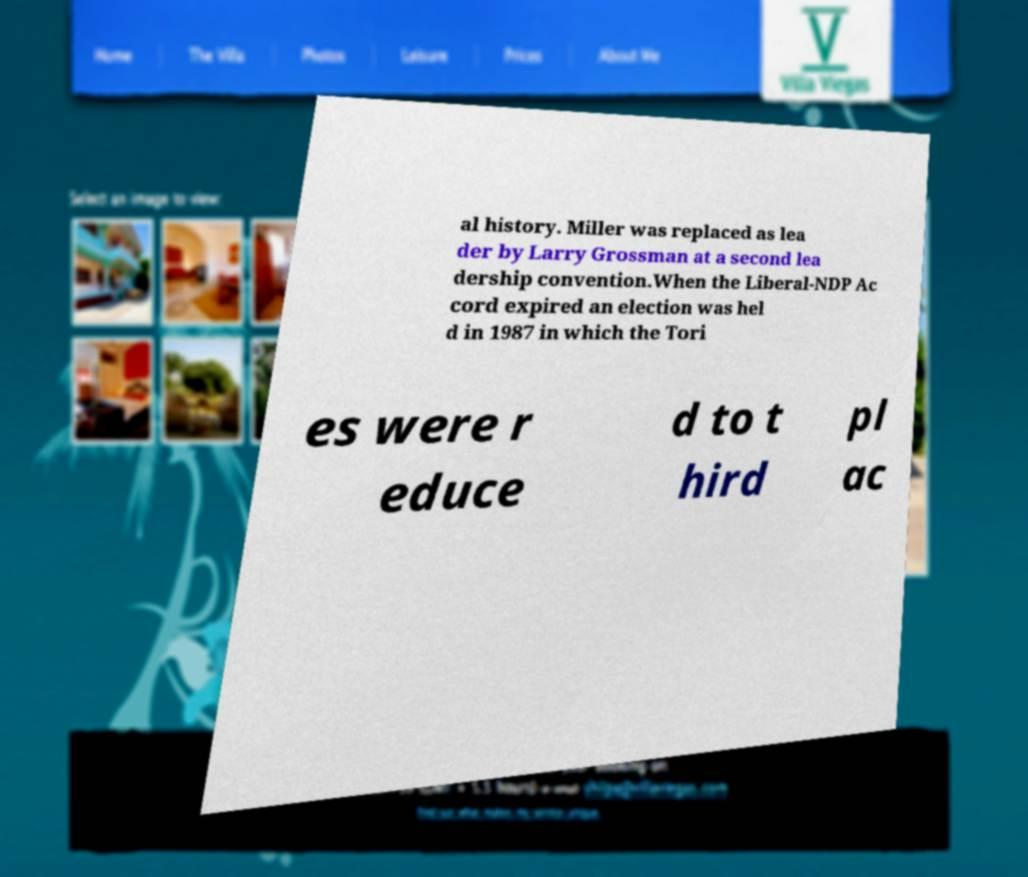I need the written content from this picture converted into text. Can you do that? al history. Miller was replaced as lea der by Larry Grossman at a second lea dership convention.When the Liberal-NDP Ac cord expired an election was hel d in 1987 in which the Tori es were r educe d to t hird pl ac 